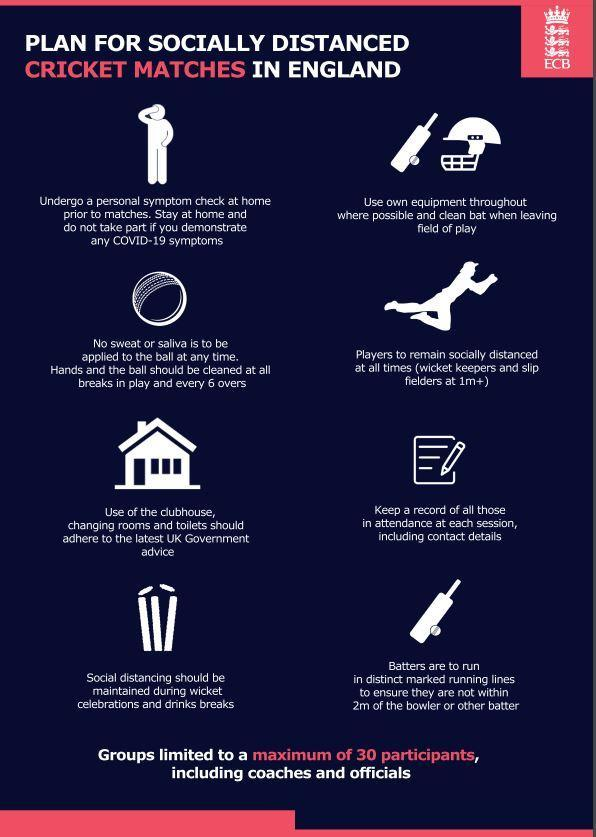What distance should be kept from other player while running between the wicket?
Answer the question with a short phrase. 2m How often the cricket ball should be cleaned? at all breaks in play and every 6 hours What is the rule when a batsmen gets out? social distancing should be maintained during wicket celebrations 